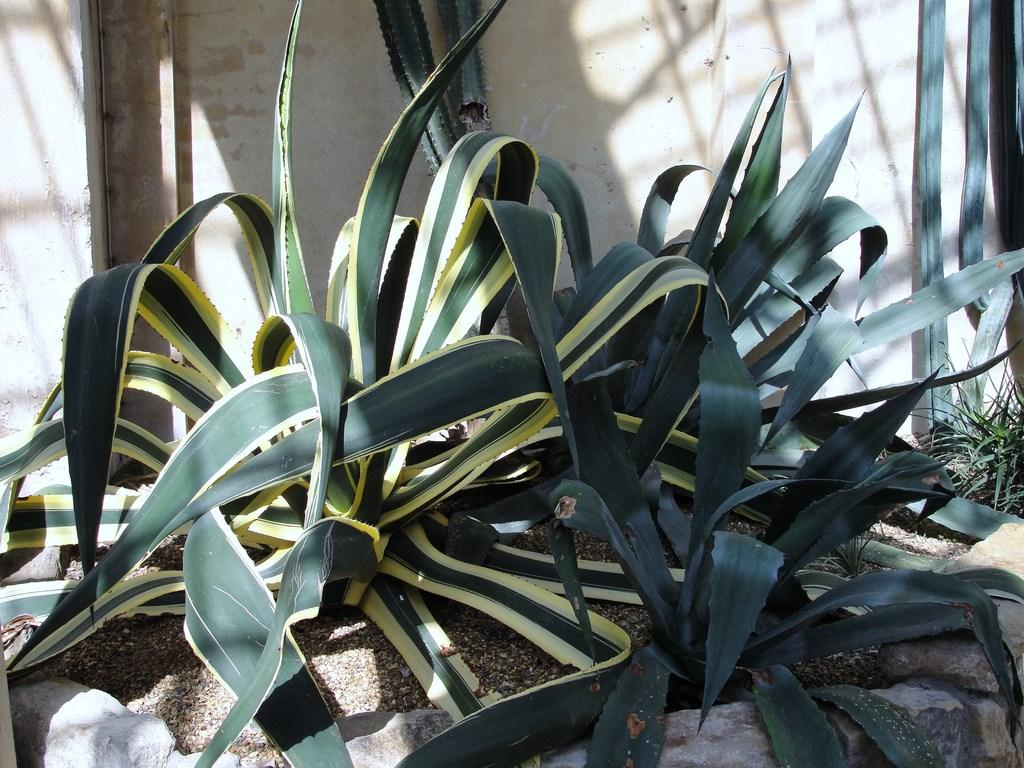How many pineapple plants are visible in the image? There are three pineapple plants in the image. What can be seen in the background of the image? There is a wall in the background of the image. What type of respect can be seen being given to the pineapple plants in the image? There is no indication of respect being given to the pineapple plants in the image. What type of spoon is used to harvest the pineapples in the image? There are no pineapples being harvested in the image, and therefore no spoon is present. 